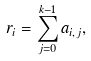Convert formula to latex. <formula><loc_0><loc_0><loc_500><loc_500>r _ { i } = \sum _ { j = 0 } ^ { k - 1 } a _ { i , j } ,</formula> 